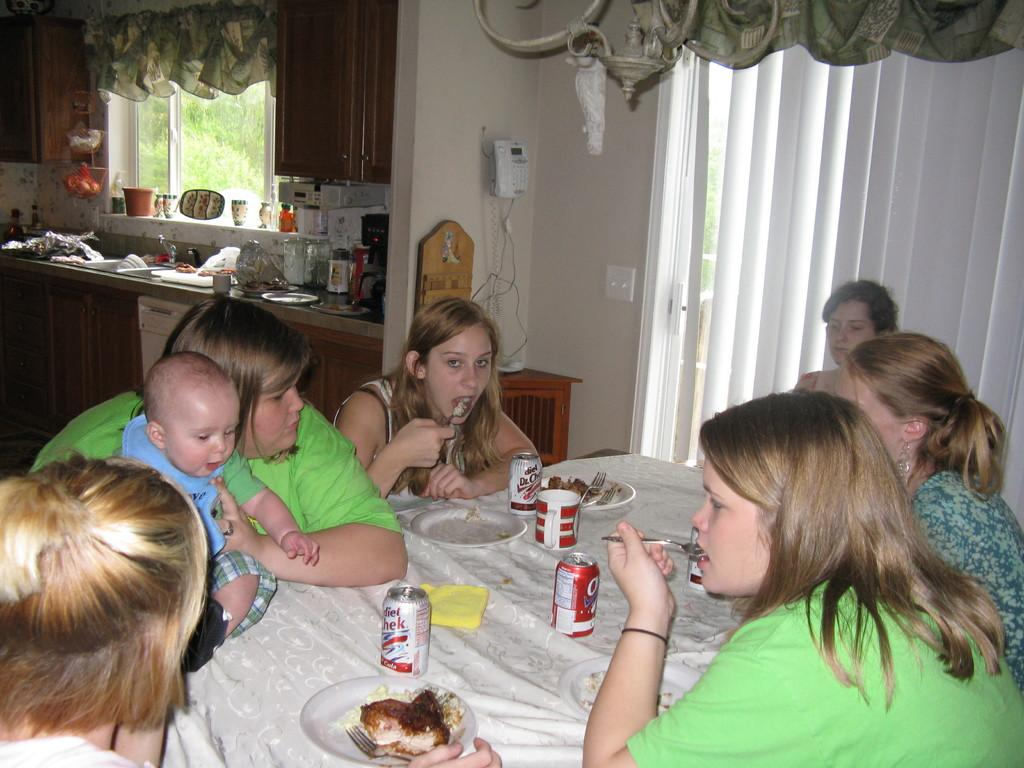What is the main subject of the image? The main subject of the image is a group of women. What are the women doing in the image? The women are sitting on chairs and having food around a table. Where was the image taken? The image was taken in a kitchen room. What can be seen on the right side of the image? There is a window with a curtain on the right side of the image. What type of nose can be seen on the goldfish in the image? There is no goldfish present in the image, and therefore no nose can be observed. 